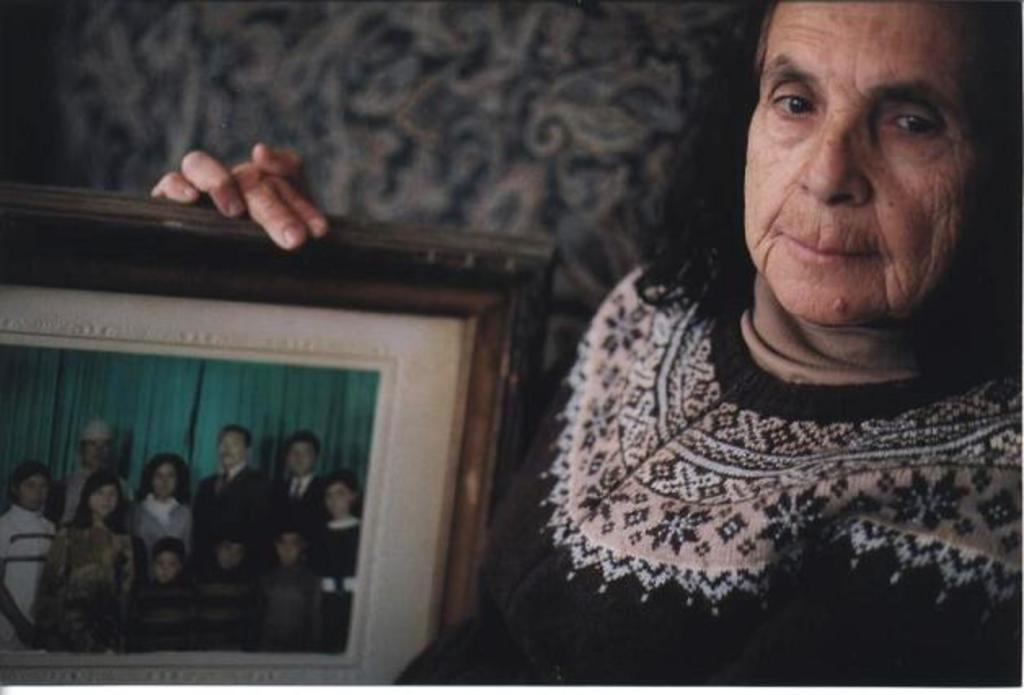Who is the main subject in the image? There is a woman in the image. What is the woman doing in the image? The woman is standing in the image. What object is the woman holding in the image? The woman is holding a photo frame in the image. What can be seen behind the woman in the image? There is a wall behind the woman in the image. What type of pets does the queen have in the image? There is no queen or pets present in the image. The image features a woman standing and holding a photo frame, with a wall behind her. 